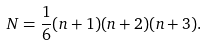Convert formula to latex. <formula><loc_0><loc_0><loc_500><loc_500>N = \frac { 1 } { 6 } ( n + 1 ) ( n + 2 ) ( n + 3 ) .</formula> 